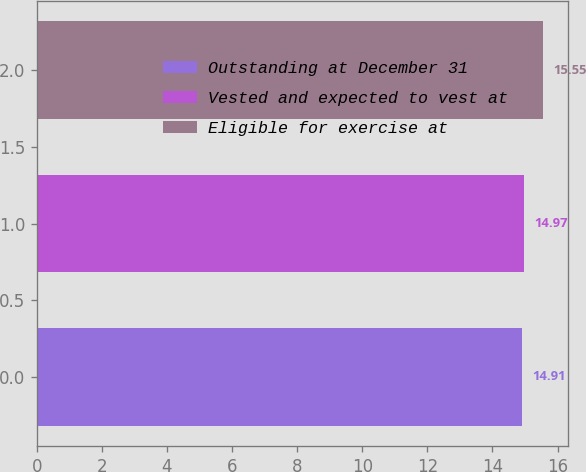Convert chart. <chart><loc_0><loc_0><loc_500><loc_500><bar_chart><fcel>Outstanding at December 31<fcel>Vested and expected to vest at<fcel>Eligible for exercise at<nl><fcel>14.91<fcel>14.97<fcel>15.55<nl></chart> 